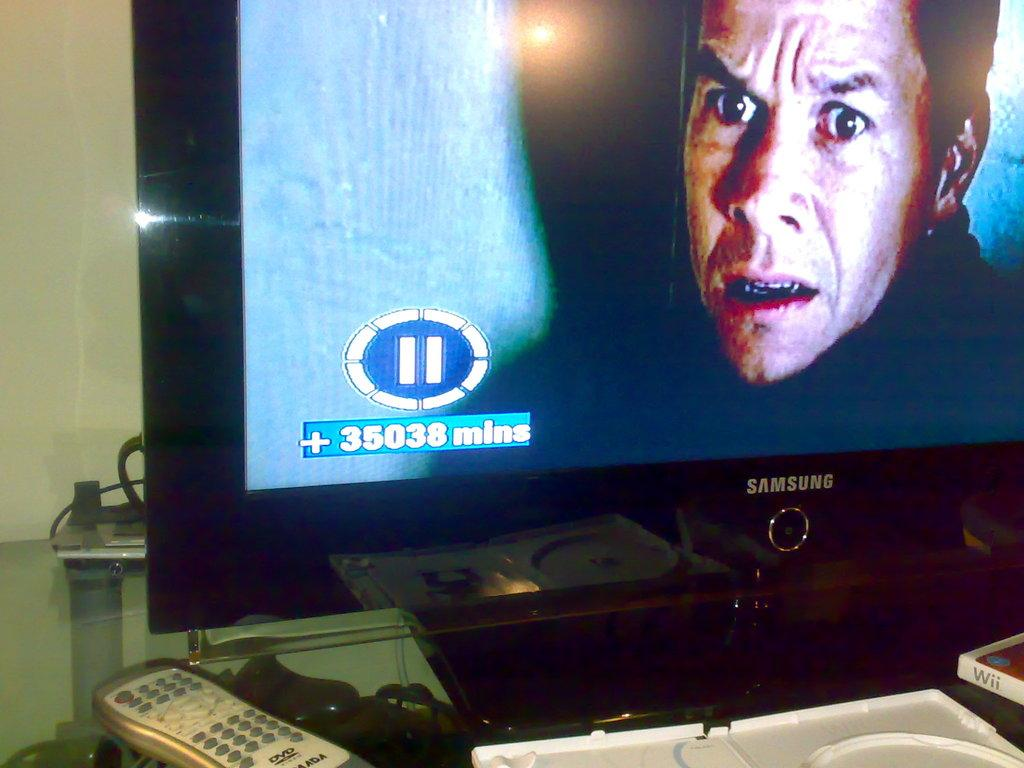<image>
Provide a brief description of the given image. a plus sign that is on the Samsung television 